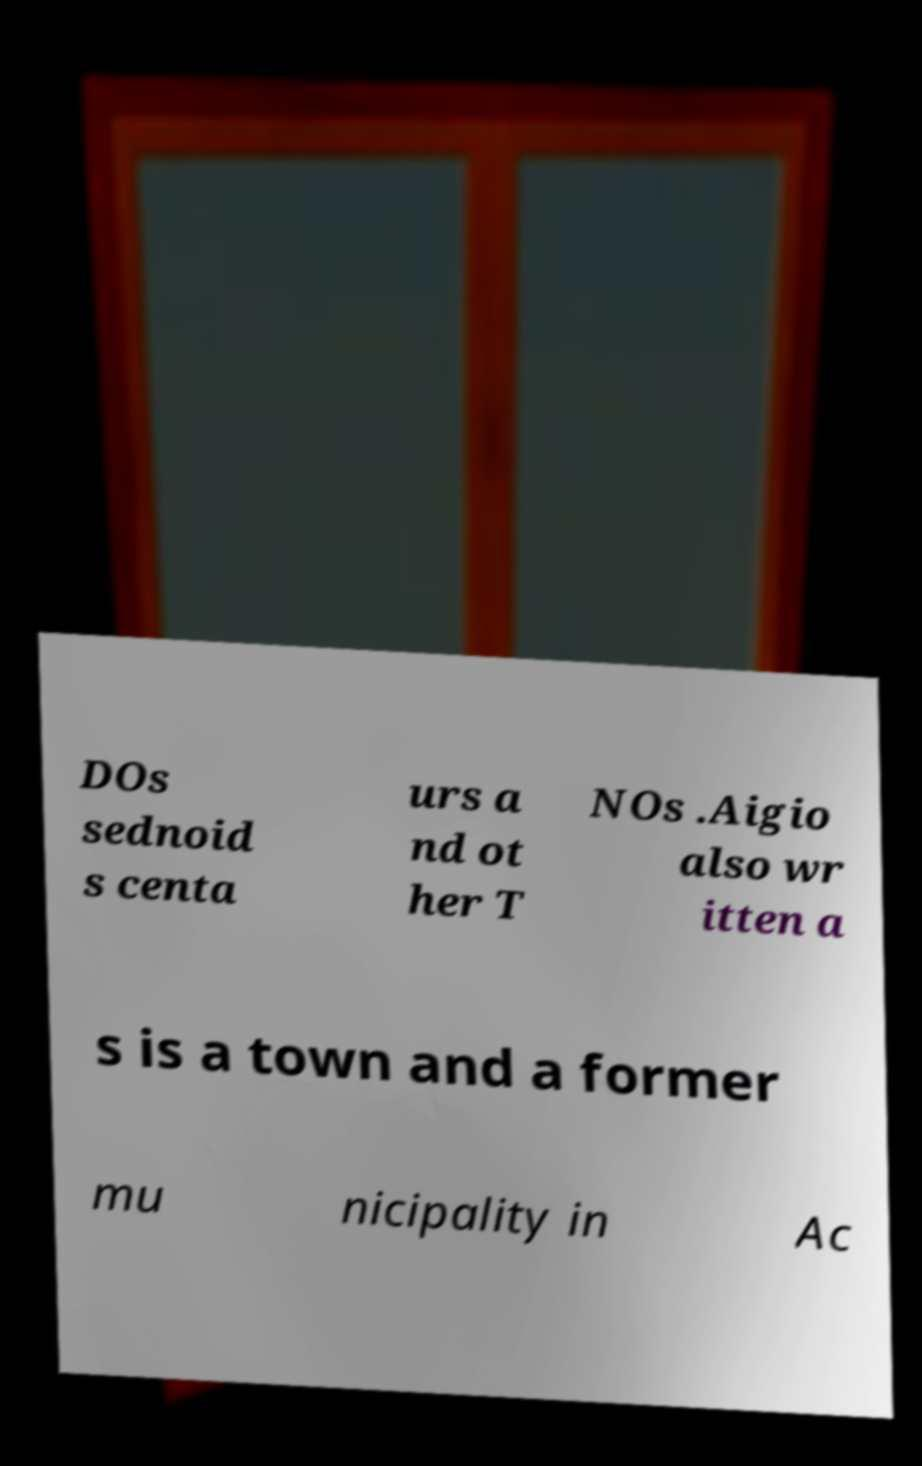Please identify and transcribe the text found in this image. DOs sednoid s centa urs a nd ot her T NOs .Aigio also wr itten a s is a town and a former mu nicipality in Ac 